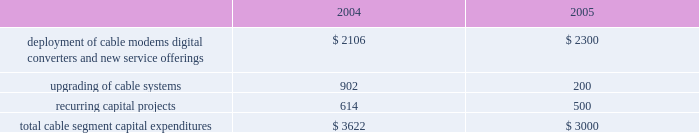Management 2019s discussion and analysis of financial condition and results of operations comcast corporation and subsidiaries28 comcast corporation and subsidiaries the exchangeable notes varies based upon the fair market value of the security to which it is indexed .
The exchangeable notes are collateralized by our investments in cablevision , microsoft and vodafone , respectively .
The comcast exchangeable notes are collateralized by our class a special common stock held in treasury .
We have settled and intend in the future to settle all of the comcast exchangeable notes using cash .
During 2004 and 2003 , we settled an aggregate of $ 847 million face amount and $ 638 million face amount , respectively , of our obligations relating to our notes exchangeable into comcast stock by delivering cash to the counterparty upon maturity of the instruments , and the equity collar agreements related to the underlying shares expired or were settled .
During 2004 and 2003 , we settled $ 2.359 billion face amount and $ 1.213 billion face amount , respectively , of our obligations relating to our exchangeable notes by delivering the underlying shares of common stock to the counterparty upon maturity of the investments .
As of december 31 , 2004 , our debt includes an aggregate of $ 1.699 billion of exchangeable notes , including $ 1.645 billion within current portion of long-term debt .
As of december 31 , 2004 , the securities we hold collateralizing the exchangeable notes were sufficient to substantially satisfy the debt obligations associated with the outstanding exchangeable notes .
Stock repurchases .
During 2004 , under our board-authorized , $ 2 billion share repurchase program , we repurchased 46.9 million shares of our class a special common stock for $ 1.328 billion .
We expect such repurchases to continue from time to time in the open market or in private transactions , subject to market conditions .
Refer to notes 8 and 10 to our consolidated financial statements for a discussion of our financing activities .
Investing activities net cash used in investing activities from continuing operations was $ 4.512 billion for the year ended december 31 , 2004 , and consists primarily of capital expenditures of $ 3.660 billion , additions to intangible and other noncurrent assets of $ 628 million and the acquisition of techtv for approximately $ 300 million .
Capital expenditures .
Our most significant recurring investing activity has been and is expected to continue to be capital expendi- tures .
The table illustrates the capital expenditures we incurred in our cable segment during 2004 and expect to incur in 2005 ( dollars in millions ) : .
The amount of our capital expenditures for 2005 and for subsequent years will depend on numerous factors , some of which are beyond our control , including competition , changes in technology and the timing and rate of deployment of new services .
Additions to intangibles .
Additions to intangibles during 2004 primarily relate to our investment in a $ 250 million long-term strategic license agreement with gemstar , multiple dwelling unit contracts of approximately $ 133 million and other licenses and software intangibles of approximately $ 168 million .
Investments .
Proceeds from sales , settlements and restructurings of investments totaled $ 228 million during 2004 , related to the sales of our non-strategic investments , including our 20% ( 20 % ) interest in dhc ventures , llc ( discovery health channel ) for approximately $ 149 million .
We consider investments that we determine to be non-strategic , highly-valued , or both to be a source of liquidity .
We consider our investment in $ 1.5 billion in time warner common-equivalent preferred stock to be an anticipated source of liquidity .
We do not have any significant contractual funding commitments with respect to any of our investments .
Refer to notes 6 and 7 to our consolidated financial statements for a discussion of our investments and our intangible assets , respectively .
Off-balance sheet arrangements we do not have any significant off-balance sheet arrangements that are reasonably likely to have a current or future effect on our financial condition , results of operations , liquidity , capital expenditures or capital resources. .
What was the approximate sum of the addition to our intangibles in 2004 in millions? 
Computations: (168 + (250 + 133))
Answer: 551.0. 